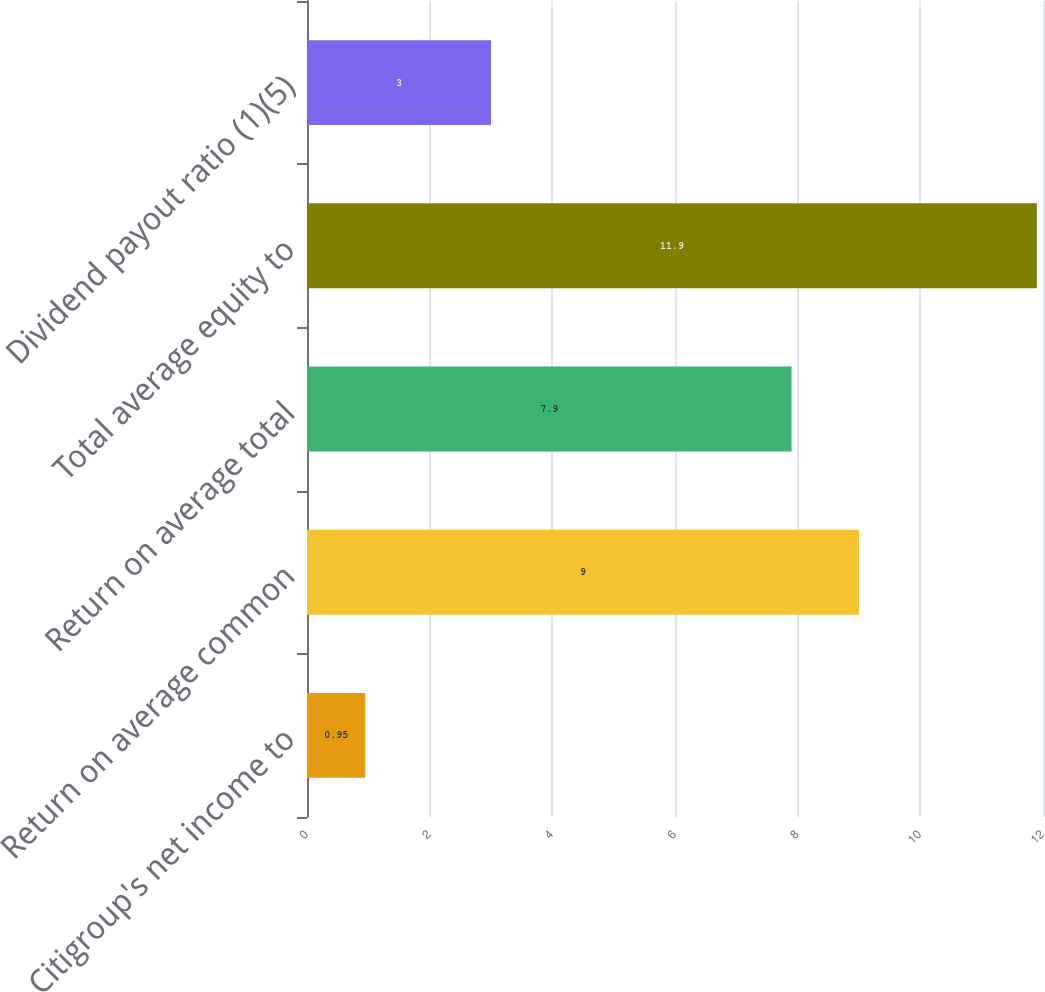Convert chart to OTSL. <chart><loc_0><loc_0><loc_500><loc_500><bar_chart><fcel>Citigroup's net income to<fcel>Return on average common<fcel>Return on average total<fcel>Total average equity to<fcel>Dividend payout ratio (1)(5)<nl><fcel>0.95<fcel>9<fcel>7.9<fcel>11.9<fcel>3<nl></chart> 